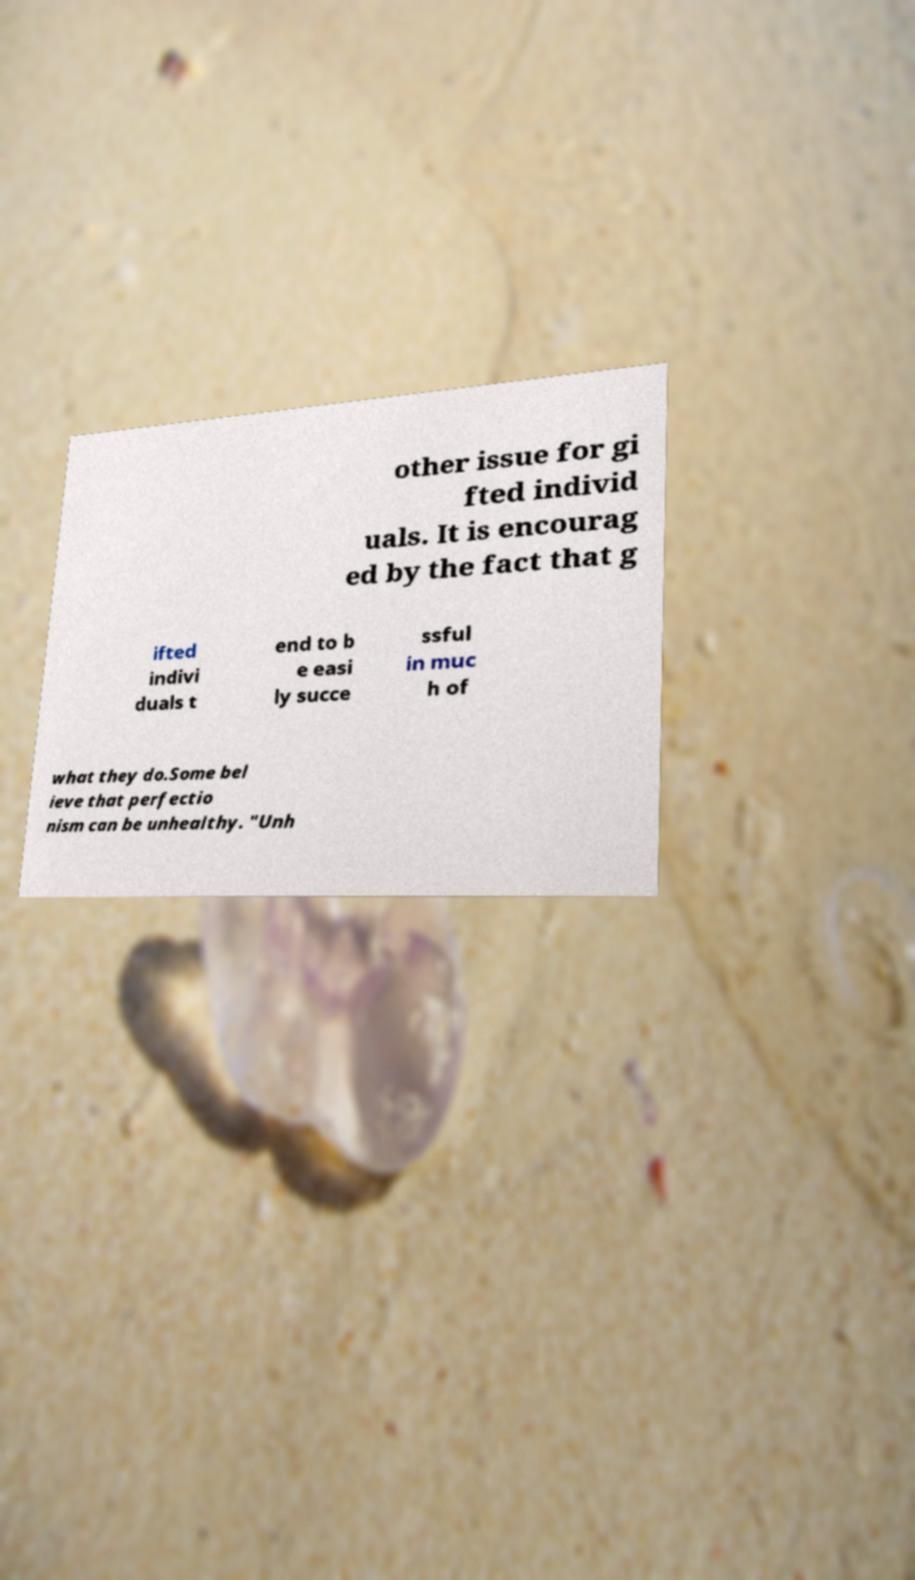For documentation purposes, I need the text within this image transcribed. Could you provide that? other issue for gi fted individ uals. It is encourag ed by the fact that g ifted indivi duals t end to b e easi ly succe ssful in muc h of what they do.Some bel ieve that perfectio nism can be unhealthy. "Unh 